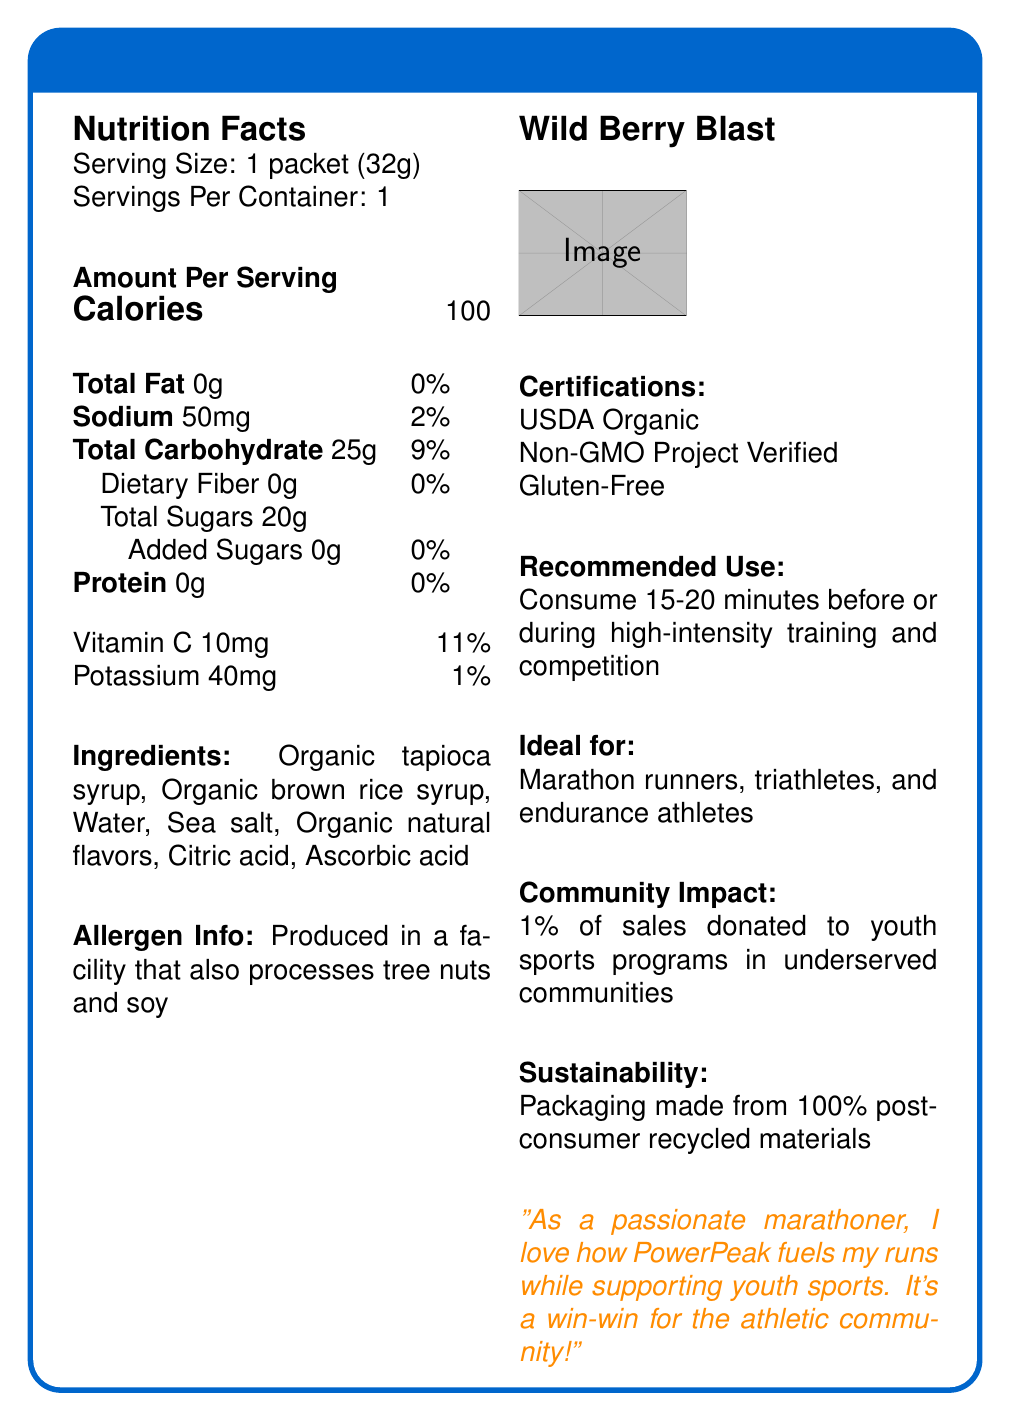what is the serving size for PowerPeak Organic Energy Gel? The serving size is explicitly mentioned as "1 packet (32g)" in the document.
Answer: 1 packet (32g) How many calories are in one serving of PowerPeak Organic Energy Gel? The document states that there are 100 calories per serving.
Answer: 100 What percentage of daily value for sodium does one packet provide? The document lists "Sodium: 50mg" with a daily value of 2%.
Answer: 2% What amount of dietary fiber is in one serving? The document shows that the dietary fiber content is "0g" per serving.
Answer: 0g Which athlete types is the gel ideal for? The document explicitly states that the product is ideal for marathon runners, triathletes, and endurance athletes.
Answer: Marathon runners, triathletes, and endurance athletes Which vitamin is present in the gel and what is its daily value percentage? The document specifies that the gel contains 10mg of Vitamin C, which is 11% of the daily value.
Answer: Vitamin C, 11% What main ingredient provides the gel's carbohydrate content? A. Organic tapioca syrup B. Sea salt C. Citric acid Among the listed ingredients, organic tapioca syrup is the primary carbohydrate source.
Answer: A. Organic tapioca syrup How much potassium does the gel contain per serving? A. 20mg B. 30mg C. 40mg The amount of potassium is specified as 40mg per serving in the document.
Answer: C. 40mg Is the product gluten-free? The document includes "Gluten-Free" as one of its certifications.
Answer: Yes Does the product contain any added sugars? The document mentions that the total sugars are 20g with 0g of added sugars.
Answer: No Summarize the main points of the PowerPeak Organic Energy Gel document. This summary captures all key aspects of the product including its nutritional benefits, targeted users, certifications, community impact, and sustainability efforts.
Answer: The document provides the nutritional information for PowerPeak Organic Energy Gel. It lists the serving size, calories, and macronutrient contents. The ingredients include organic syrups and natural flavors, and the product is ideal for endurance athletes. It is certified organic, non-GMO, and gluten-free. Packaging is eco-friendly, and 1% of sales support youth sports programs. What is the flavor of PowerPeak Organic Energy Gel? The document mentions that the flavor is "Wild Berry Blast."
Answer: Wild Berry Blast What is the recommended use of this energy gel during training? The document advises consuming the gel 15-20 minutes before or during high-intensity training and competition.
Answer: Consume 15-20 minutes before or during high-intensity training and competition What percentage of the product’s sales is donated to youth sports programs? The document states that 1% of sales are donated to youth sports programs in underserved communities.
Answer: 1% Does the product contain any allergens? The allergen information in the document notes that the product is made in a facility that processes tree nuts and soy.
Answer: Produced in a facility that also processes tree nuts and soy The gel contains ingredients such as organic natural flavors and sea salt. What is the role of citric acid in the product? The document does not provide information on the specific role of citric acid in the product.
Answer: Not enough information What are the sustainability features of the gel's packaging? The document notes that the packaging is made from 100% post-consumer recycled materials.
Answer: Packaging made from 100% post-consumer recycled materials 